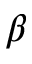Convert formula to latex. <formula><loc_0><loc_0><loc_500><loc_500>\beta</formula> 